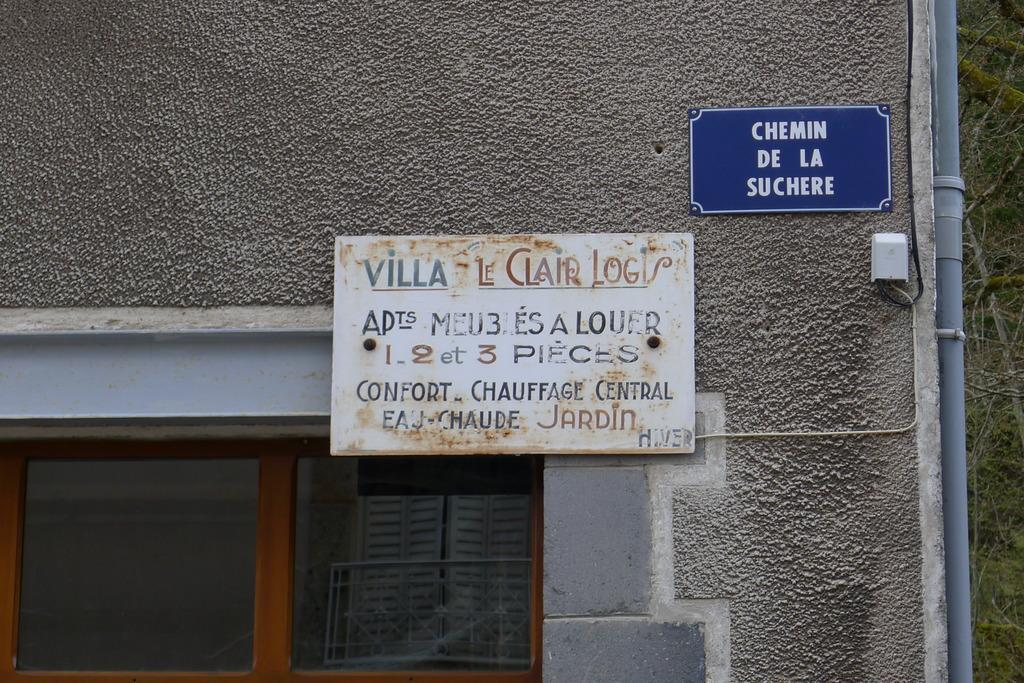What is located in the center of the image? There is a wall in the center of the image. Can you identify any openings in the wall? Yes, there is a window in the image. What is attached to the wall? There is a name board in the image. What can be seen to the right side of the image? There are trees to the right side of the image. What type of object is present in the image that is typically used for transporting fluids? There is a pipe in the image. What type of vacation is depicted in the image? There is no vacation depicted in the image; it features a wall, window, name board, trees, and a pipe. What act is being performed by the trees in the image? The trees in the image are not performing any act; they are stationary and not capable of performing actions. 